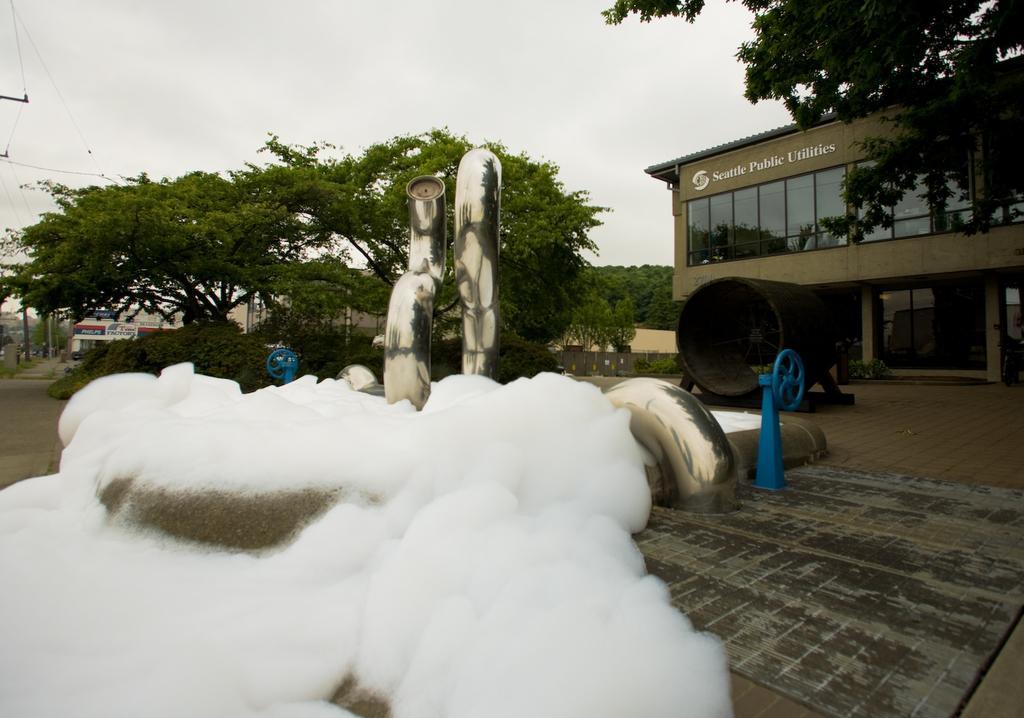Can you describe this image briefly? In this image, on the right side, we can see a tree, building, glass window. On the right side, we can also see a metal instrument which is placed on the floor. In the middle of the image, we can see a snow which is placed on some object. In the background, we can see some metal pipes, metal instrument, trees, plants, building, electric pole, electric wires. At the top, we can see a sky which is cloudy, at the bottom, we can see a road and a floor. 